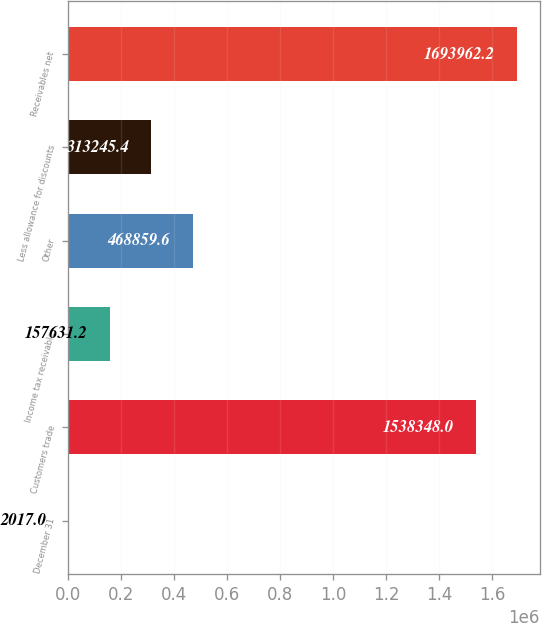Convert chart. <chart><loc_0><loc_0><loc_500><loc_500><bar_chart><fcel>December 31<fcel>Customers trade<fcel>Income tax receivable<fcel>Other<fcel>Less allowance for discounts<fcel>Receivables net<nl><fcel>2017<fcel>1.53835e+06<fcel>157631<fcel>468860<fcel>313245<fcel>1.69396e+06<nl></chart> 